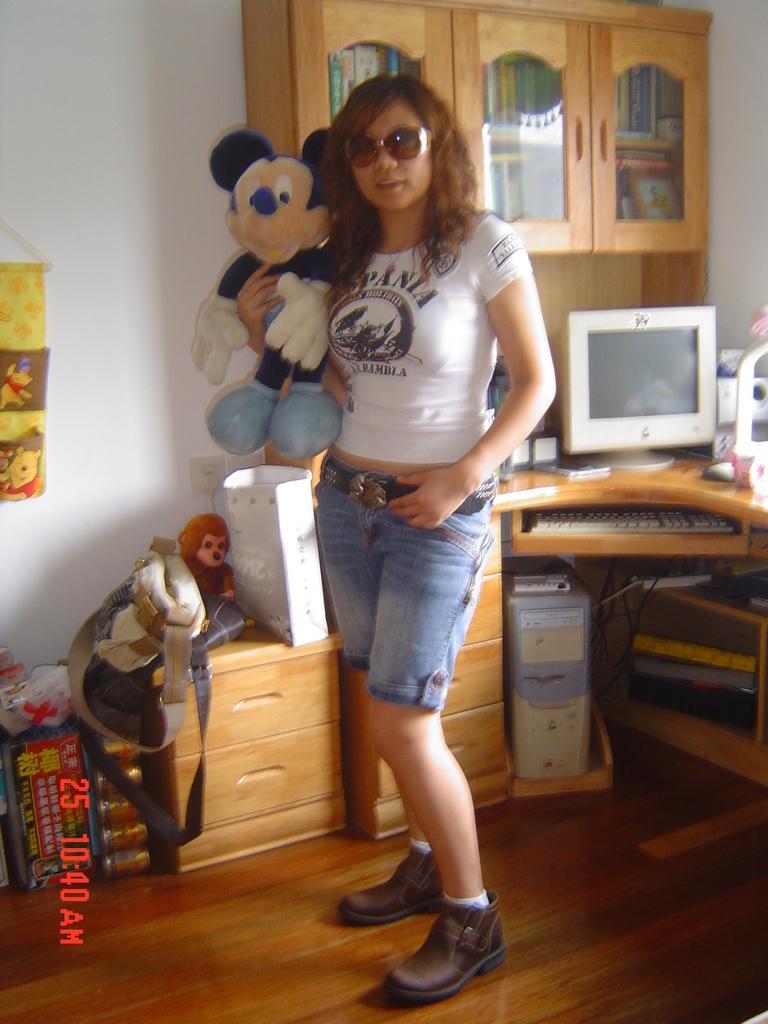Please provide a concise description of this image. In this image there is a woman holding a Mickey mouse. She is wearing a white t shirt, blue shorts, brown shoes and a goggles. Behind her there is a table. On the table there is a computer, keyboard and CPU and etc. To the left side there is a bag and a toy. In the top right there is a desk. 